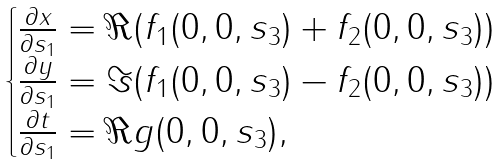<formula> <loc_0><loc_0><loc_500><loc_500>\begin{cases} \frac { \partial x } { \partial s _ { 1 } } = \Re ( f _ { 1 } ( 0 , 0 , s _ { 3 } ) + f _ { 2 } ( 0 , 0 , s _ { 3 } ) ) \\ \frac { \partial y } { \partial s _ { 1 } } = \Im ( f _ { 1 } ( 0 , 0 , s _ { 3 } ) - f _ { 2 } ( 0 , 0 , s _ { 3 } ) ) \\ \frac { \partial t } { \partial s _ { 1 } } = \Re g ( 0 , 0 , s _ { 3 } ) , \end{cases}</formula> 